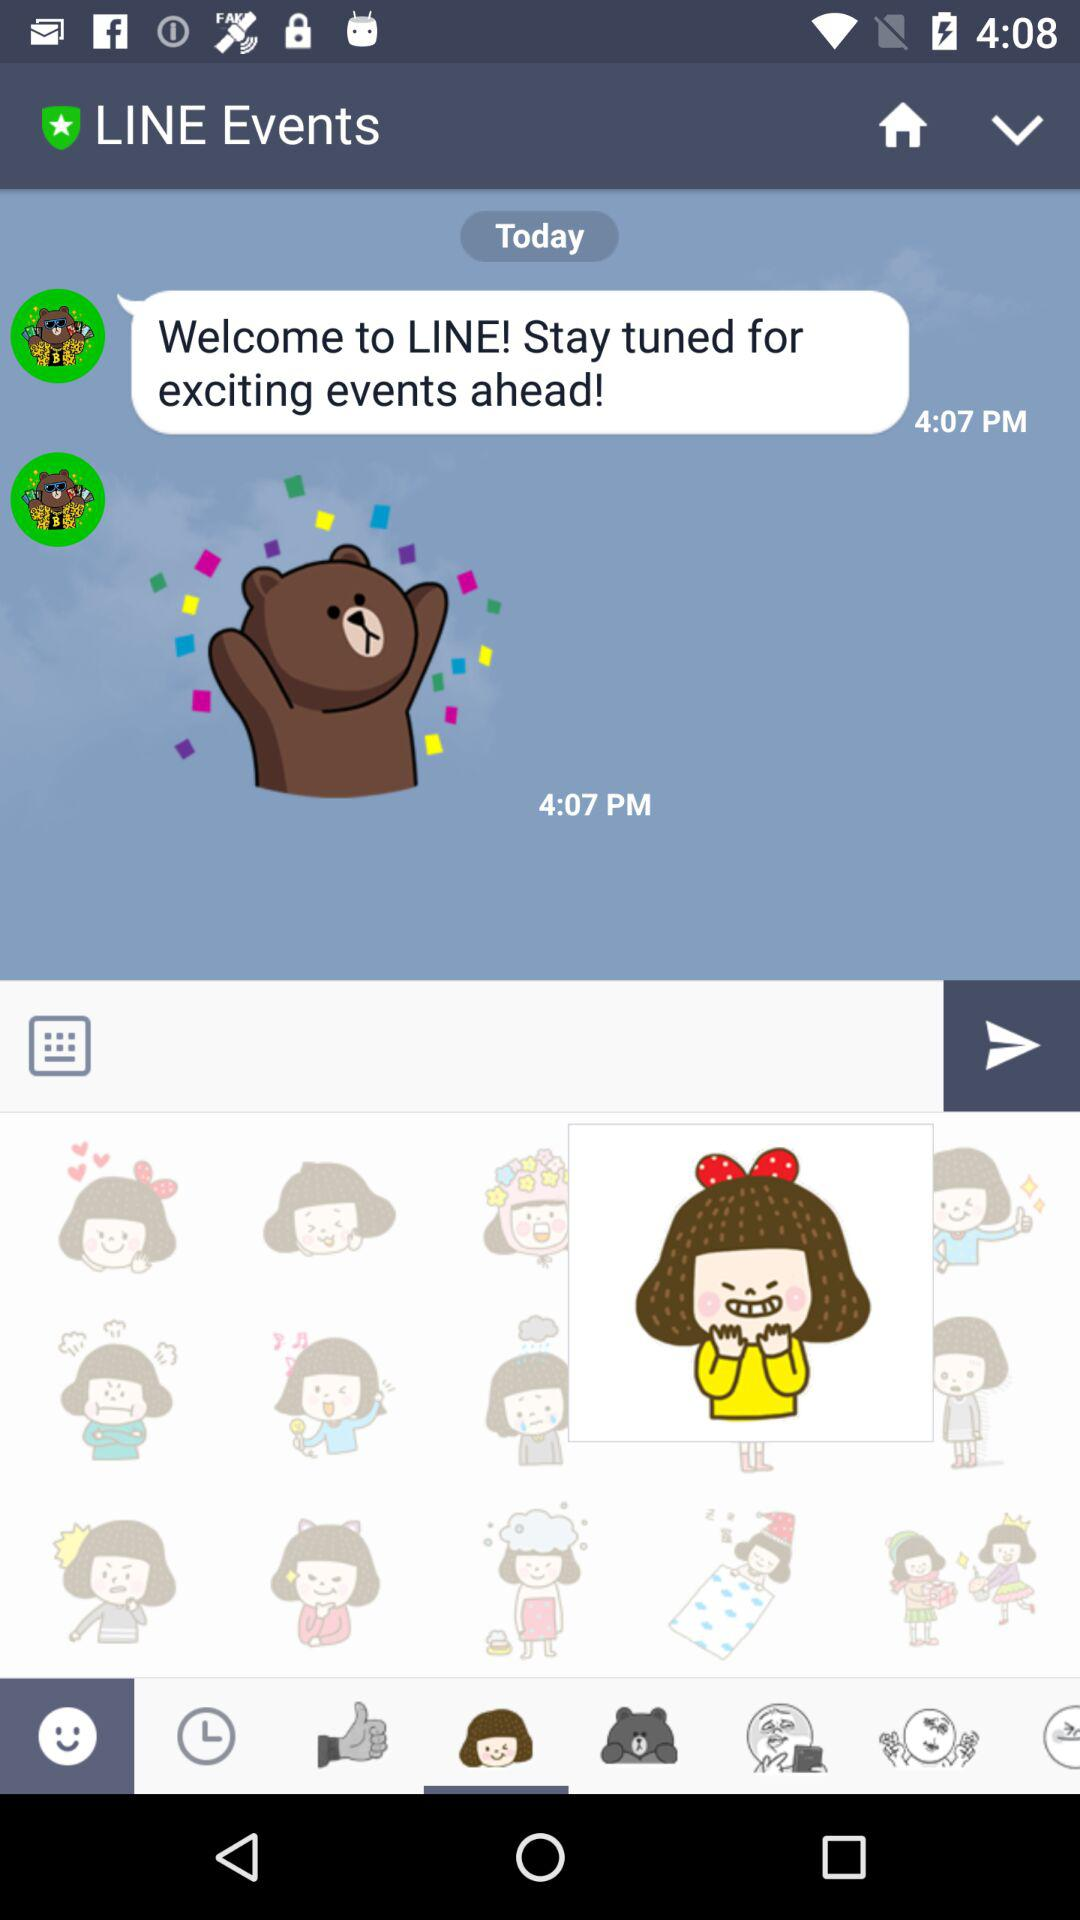What is entered in the text box?
When the provided information is insufficient, respond with <no answer>. <no answer> 